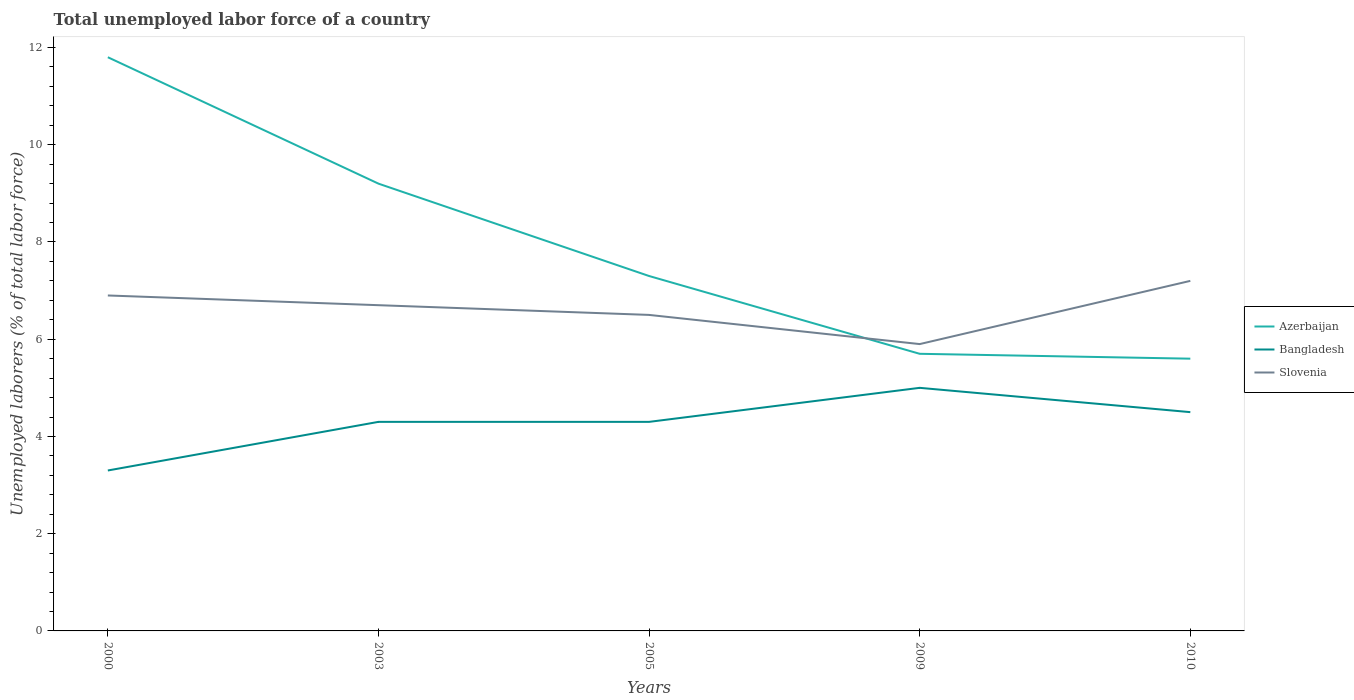Is the number of lines equal to the number of legend labels?
Your response must be concise. Yes. Across all years, what is the maximum total unemployed labor force in Bangladesh?
Provide a short and direct response. 3.3. What is the total total unemployed labor force in Bangladesh in the graph?
Provide a short and direct response. -0.7. What is the difference between the highest and the second highest total unemployed labor force in Slovenia?
Offer a terse response. 1.3. Are the values on the major ticks of Y-axis written in scientific E-notation?
Ensure brevity in your answer.  No. Does the graph contain any zero values?
Give a very brief answer. No. Does the graph contain grids?
Provide a succinct answer. No. How many legend labels are there?
Keep it short and to the point. 3. How are the legend labels stacked?
Provide a short and direct response. Vertical. What is the title of the graph?
Your response must be concise. Total unemployed labor force of a country. What is the label or title of the X-axis?
Ensure brevity in your answer.  Years. What is the label or title of the Y-axis?
Your answer should be very brief. Unemployed laborers (% of total labor force). What is the Unemployed laborers (% of total labor force) of Azerbaijan in 2000?
Provide a short and direct response. 11.8. What is the Unemployed laborers (% of total labor force) of Bangladesh in 2000?
Your answer should be compact. 3.3. What is the Unemployed laborers (% of total labor force) of Slovenia in 2000?
Your answer should be compact. 6.9. What is the Unemployed laborers (% of total labor force) in Azerbaijan in 2003?
Your response must be concise. 9.2. What is the Unemployed laborers (% of total labor force) in Bangladesh in 2003?
Your answer should be compact. 4.3. What is the Unemployed laborers (% of total labor force) of Slovenia in 2003?
Make the answer very short. 6.7. What is the Unemployed laborers (% of total labor force) of Azerbaijan in 2005?
Make the answer very short. 7.3. What is the Unemployed laborers (% of total labor force) in Bangladesh in 2005?
Your answer should be compact. 4.3. What is the Unemployed laborers (% of total labor force) in Azerbaijan in 2009?
Your answer should be very brief. 5.7. What is the Unemployed laborers (% of total labor force) in Bangladesh in 2009?
Provide a succinct answer. 5. What is the Unemployed laborers (% of total labor force) in Slovenia in 2009?
Offer a very short reply. 5.9. What is the Unemployed laborers (% of total labor force) in Azerbaijan in 2010?
Provide a succinct answer. 5.6. What is the Unemployed laborers (% of total labor force) in Bangladesh in 2010?
Your response must be concise. 4.5. What is the Unemployed laborers (% of total labor force) of Slovenia in 2010?
Give a very brief answer. 7.2. Across all years, what is the maximum Unemployed laborers (% of total labor force) in Azerbaijan?
Provide a short and direct response. 11.8. Across all years, what is the maximum Unemployed laborers (% of total labor force) of Bangladesh?
Provide a succinct answer. 5. Across all years, what is the maximum Unemployed laborers (% of total labor force) in Slovenia?
Offer a very short reply. 7.2. Across all years, what is the minimum Unemployed laborers (% of total labor force) in Azerbaijan?
Offer a very short reply. 5.6. Across all years, what is the minimum Unemployed laborers (% of total labor force) in Bangladesh?
Make the answer very short. 3.3. Across all years, what is the minimum Unemployed laborers (% of total labor force) in Slovenia?
Give a very brief answer. 5.9. What is the total Unemployed laborers (% of total labor force) of Azerbaijan in the graph?
Provide a short and direct response. 39.6. What is the total Unemployed laborers (% of total labor force) of Bangladesh in the graph?
Your response must be concise. 21.4. What is the total Unemployed laborers (% of total labor force) in Slovenia in the graph?
Ensure brevity in your answer.  33.2. What is the difference between the Unemployed laborers (% of total labor force) of Azerbaijan in 2000 and that in 2003?
Offer a terse response. 2.6. What is the difference between the Unemployed laborers (% of total labor force) in Bangladesh in 2000 and that in 2003?
Ensure brevity in your answer.  -1. What is the difference between the Unemployed laborers (% of total labor force) in Slovenia in 2000 and that in 2003?
Your answer should be compact. 0.2. What is the difference between the Unemployed laborers (% of total labor force) of Bangladesh in 2000 and that in 2009?
Your answer should be compact. -1.7. What is the difference between the Unemployed laborers (% of total labor force) of Bangladesh in 2000 and that in 2010?
Provide a succinct answer. -1.2. What is the difference between the Unemployed laborers (% of total labor force) in Azerbaijan in 2003 and that in 2005?
Keep it short and to the point. 1.9. What is the difference between the Unemployed laborers (% of total labor force) in Bangladesh in 2003 and that in 2005?
Your answer should be compact. 0. What is the difference between the Unemployed laborers (% of total labor force) of Slovenia in 2003 and that in 2005?
Your answer should be very brief. 0.2. What is the difference between the Unemployed laborers (% of total labor force) of Slovenia in 2003 and that in 2009?
Make the answer very short. 0.8. What is the difference between the Unemployed laborers (% of total labor force) in Bangladesh in 2003 and that in 2010?
Provide a succinct answer. -0.2. What is the difference between the Unemployed laborers (% of total labor force) in Slovenia in 2005 and that in 2009?
Your answer should be very brief. 0.6. What is the difference between the Unemployed laborers (% of total labor force) of Bangladesh in 2005 and that in 2010?
Your answer should be compact. -0.2. What is the difference between the Unemployed laborers (% of total labor force) of Slovenia in 2005 and that in 2010?
Offer a terse response. -0.7. What is the difference between the Unemployed laborers (% of total labor force) of Slovenia in 2009 and that in 2010?
Your response must be concise. -1.3. What is the difference between the Unemployed laborers (% of total labor force) of Azerbaijan in 2000 and the Unemployed laborers (% of total labor force) of Bangladesh in 2003?
Offer a very short reply. 7.5. What is the difference between the Unemployed laborers (% of total labor force) of Bangladesh in 2000 and the Unemployed laborers (% of total labor force) of Slovenia in 2003?
Provide a short and direct response. -3.4. What is the difference between the Unemployed laborers (% of total labor force) in Azerbaijan in 2000 and the Unemployed laborers (% of total labor force) in Bangladesh in 2005?
Give a very brief answer. 7.5. What is the difference between the Unemployed laborers (% of total labor force) in Azerbaijan in 2000 and the Unemployed laborers (% of total labor force) in Slovenia in 2005?
Provide a succinct answer. 5.3. What is the difference between the Unemployed laborers (% of total labor force) of Azerbaijan in 2000 and the Unemployed laborers (% of total labor force) of Slovenia in 2009?
Make the answer very short. 5.9. What is the difference between the Unemployed laborers (% of total labor force) in Bangladesh in 2000 and the Unemployed laborers (% of total labor force) in Slovenia in 2009?
Offer a terse response. -2.6. What is the difference between the Unemployed laborers (% of total labor force) of Azerbaijan in 2000 and the Unemployed laborers (% of total labor force) of Bangladesh in 2010?
Keep it short and to the point. 7.3. What is the difference between the Unemployed laborers (% of total labor force) of Azerbaijan in 2000 and the Unemployed laborers (% of total labor force) of Slovenia in 2010?
Keep it short and to the point. 4.6. What is the difference between the Unemployed laborers (% of total labor force) of Bangladesh in 2000 and the Unemployed laborers (% of total labor force) of Slovenia in 2010?
Your answer should be compact. -3.9. What is the difference between the Unemployed laborers (% of total labor force) in Azerbaijan in 2003 and the Unemployed laborers (% of total labor force) in Slovenia in 2005?
Your answer should be compact. 2.7. What is the difference between the Unemployed laborers (% of total labor force) in Azerbaijan in 2003 and the Unemployed laborers (% of total labor force) in Bangladesh in 2009?
Offer a very short reply. 4.2. What is the difference between the Unemployed laborers (% of total labor force) in Azerbaijan in 2003 and the Unemployed laborers (% of total labor force) in Bangladesh in 2010?
Provide a short and direct response. 4.7. What is the difference between the Unemployed laborers (% of total labor force) of Azerbaijan in 2003 and the Unemployed laborers (% of total labor force) of Slovenia in 2010?
Offer a terse response. 2. What is the difference between the Unemployed laborers (% of total labor force) in Bangladesh in 2003 and the Unemployed laborers (% of total labor force) in Slovenia in 2010?
Offer a terse response. -2.9. What is the difference between the Unemployed laborers (% of total labor force) of Bangladesh in 2005 and the Unemployed laborers (% of total labor force) of Slovenia in 2010?
Ensure brevity in your answer.  -2.9. What is the difference between the Unemployed laborers (% of total labor force) of Azerbaijan in 2009 and the Unemployed laborers (% of total labor force) of Bangladesh in 2010?
Make the answer very short. 1.2. What is the difference between the Unemployed laborers (% of total labor force) in Azerbaijan in 2009 and the Unemployed laborers (% of total labor force) in Slovenia in 2010?
Provide a short and direct response. -1.5. What is the average Unemployed laborers (% of total labor force) in Azerbaijan per year?
Your answer should be very brief. 7.92. What is the average Unemployed laborers (% of total labor force) of Bangladesh per year?
Ensure brevity in your answer.  4.28. What is the average Unemployed laborers (% of total labor force) of Slovenia per year?
Provide a short and direct response. 6.64. In the year 2000, what is the difference between the Unemployed laborers (% of total labor force) in Azerbaijan and Unemployed laborers (% of total labor force) in Slovenia?
Make the answer very short. 4.9. In the year 2005, what is the difference between the Unemployed laborers (% of total labor force) of Azerbaijan and Unemployed laborers (% of total labor force) of Bangladesh?
Your response must be concise. 3. In the year 2009, what is the difference between the Unemployed laborers (% of total labor force) of Azerbaijan and Unemployed laborers (% of total labor force) of Bangladesh?
Offer a very short reply. 0.7. In the year 2010, what is the difference between the Unemployed laborers (% of total labor force) of Azerbaijan and Unemployed laborers (% of total labor force) of Slovenia?
Ensure brevity in your answer.  -1.6. What is the ratio of the Unemployed laborers (% of total labor force) of Azerbaijan in 2000 to that in 2003?
Provide a succinct answer. 1.28. What is the ratio of the Unemployed laborers (% of total labor force) in Bangladesh in 2000 to that in 2003?
Give a very brief answer. 0.77. What is the ratio of the Unemployed laborers (% of total labor force) of Slovenia in 2000 to that in 2003?
Provide a succinct answer. 1.03. What is the ratio of the Unemployed laborers (% of total labor force) of Azerbaijan in 2000 to that in 2005?
Your answer should be very brief. 1.62. What is the ratio of the Unemployed laborers (% of total labor force) in Bangladesh in 2000 to that in 2005?
Offer a very short reply. 0.77. What is the ratio of the Unemployed laborers (% of total labor force) in Slovenia in 2000 to that in 2005?
Give a very brief answer. 1.06. What is the ratio of the Unemployed laborers (% of total labor force) of Azerbaijan in 2000 to that in 2009?
Your answer should be very brief. 2.07. What is the ratio of the Unemployed laborers (% of total labor force) of Bangladesh in 2000 to that in 2009?
Keep it short and to the point. 0.66. What is the ratio of the Unemployed laborers (% of total labor force) of Slovenia in 2000 to that in 2009?
Your answer should be compact. 1.17. What is the ratio of the Unemployed laborers (% of total labor force) in Azerbaijan in 2000 to that in 2010?
Give a very brief answer. 2.11. What is the ratio of the Unemployed laborers (% of total labor force) in Bangladesh in 2000 to that in 2010?
Make the answer very short. 0.73. What is the ratio of the Unemployed laborers (% of total labor force) in Slovenia in 2000 to that in 2010?
Your response must be concise. 0.96. What is the ratio of the Unemployed laborers (% of total labor force) of Azerbaijan in 2003 to that in 2005?
Make the answer very short. 1.26. What is the ratio of the Unemployed laborers (% of total labor force) in Slovenia in 2003 to that in 2005?
Keep it short and to the point. 1.03. What is the ratio of the Unemployed laborers (% of total labor force) of Azerbaijan in 2003 to that in 2009?
Provide a succinct answer. 1.61. What is the ratio of the Unemployed laborers (% of total labor force) of Bangladesh in 2003 to that in 2009?
Keep it short and to the point. 0.86. What is the ratio of the Unemployed laborers (% of total labor force) in Slovenia in 2003 to that in 2009?
Keep it short and to the point. 1.14. What is the ratio of the Unemployed laborers (% of total labor force) of Azerbaijan in 2003 to that in 2010?
Ensure brevity in your answer.  1.64. What is the ratio of the Unemployed laborers (% of total labor force) of Bangladesh in 2003 to that in 2010?
Keep it short and to the point. 0.96. What is the ratio of the Unemployed laborers (% of total labor force) of Slovenia in 2003 to that in 2010?
Provide a succinct answer. 0.93. What is the ratio of the Unemployed laborers (% of total labor force) of Azerbaijan in 2005 to that in 2009?
Offer a terse response. 1.28. What is the ratio of the Unemployed laborers (% of total labor force) in Bangladesh in 2005 to that in 2009?
Your answer should be very brief. 0.86. What is the ratio of the Unemployed laborers (% of total labor force) in Slovenia in 2005 to that in 2009?
Your response must be concise. 1.1. What is the ratio of the Unemployed laborers (% of total labor force) in Azerbaijan in 2005 to that in 2010?
Keep it short and to the point. 1.3. What is the ratio of the Unemployed laborers (% of total labor force) of Bangladesh in 2005 to that in 2010?
Provide a succinct answer. 0.96. What is the ratio of the Unemployed laborers (% of total labor force) of Slovenia in 2005 to that in 2010?
Provide a succinct answer. 0.9. What is the ratio of the Unemployed laborers (% of total labor force) in Azerbaijan in 2009 to that in 2010?
Give a very brief answer. 1.02. What is the ratio of the Unemployed laborers (% of total labor force) of Bangladesh in 2009 to that in 2010?
Provide a succinct answer. 1.11. What is the ratio of the Unemployed laborers (% of total labor force) in Slovenia in 2009 to that in 2010?
Your answer should be compact. 0.82. What is the difference between the highest and the lowest Unemployed laborers (% of total labor force) in Bangladesh?
Make the answer very short. 1.7. What is the difference between the highest and the lowest Unemployed laborers (% of total labor force) of Slovenia?
Ensure brevity in your answer.  1.3. 